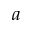<formula> <loc_0><loc_0><loc_500><loc_500>a</formula> 